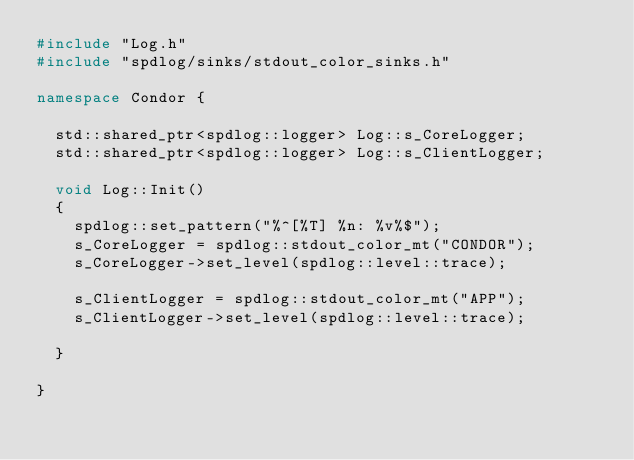Convert code to text. <code><loc_0><loc_0><loc_500><loc_500><_C++_>#include "Log.h"
#include "spdlog/sinks/stdout_color_sinks.h"

namespace Condor {

	std::shared_ptr<spdlog::logger> Log::s_CoreLogger;
	std::shared_ptr<spdlog::logger> Log::s_ClientLogger;

	void Log::Init()
	{
		spdlog::set_pattern("%^[%T] %n: %v%$");
		s_CoreLogger = spdlog::stdout_color_mt("CONDOR");
		s_CoreLogger->set_level(spdlog::level::trace);

		s_ClientLogger = spdlog::stdout_color_mt("APP");
		s_ClientLogger->set_level(spdlog::level::trace);

	}

}

</code> 